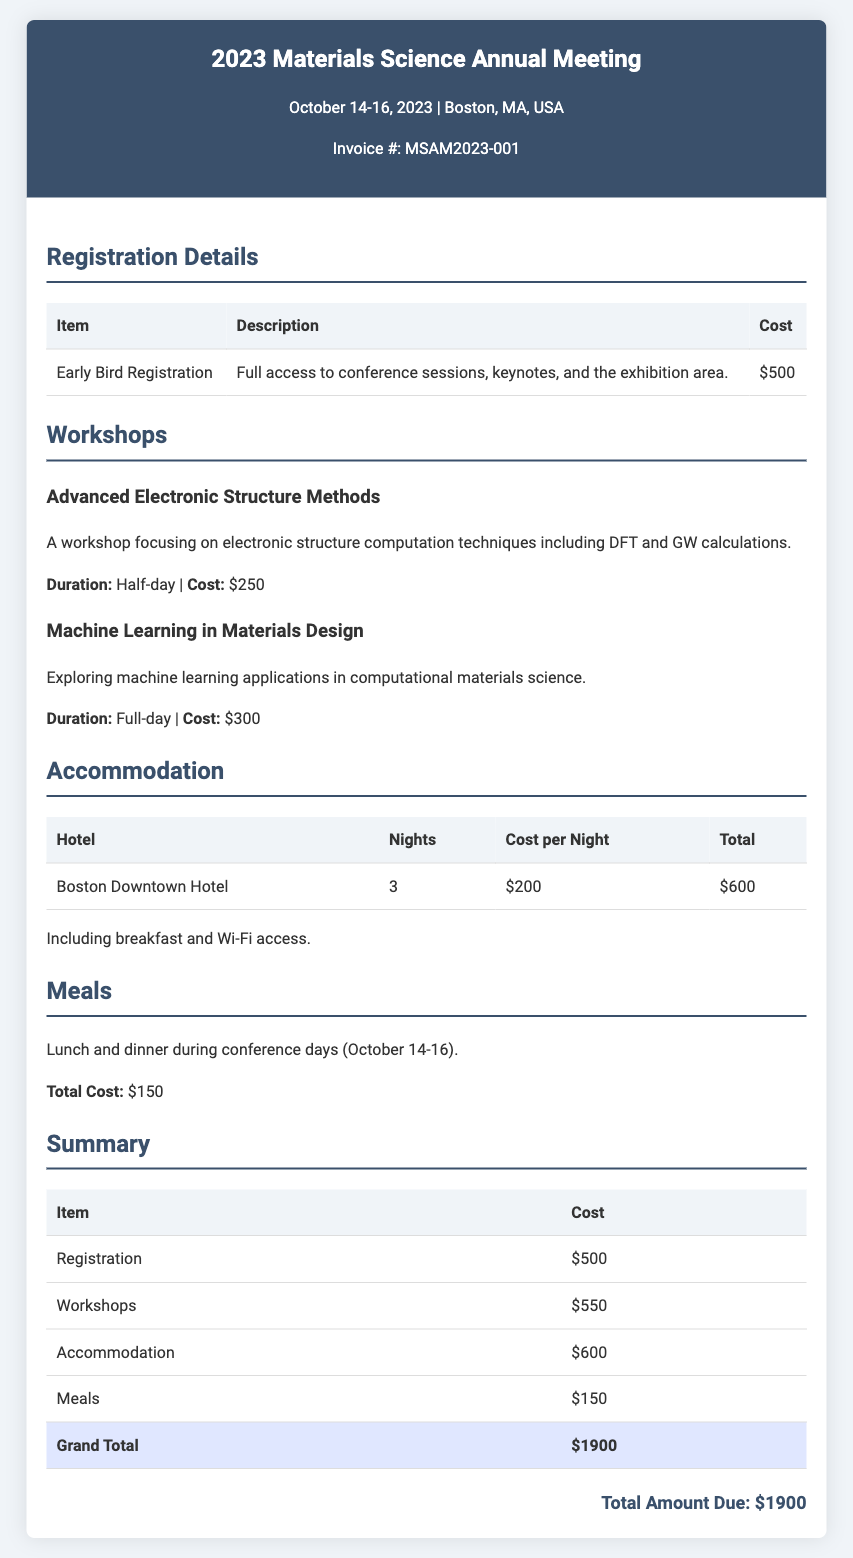What is the total amount due? The total amount due is emphasized at the bottom of the invoice, indicating the overall cost for attending the conference.
Answer: $1900 What is the cost of the Advanced Electronic Structure Methods workshop? The cost for this specific workshop is listed under the workshops section of the invoice.
Answer: $250 How many nights of accommodation are included? The invoice specifies the number of nights for the accommodation in the table for the hotel details.
Answer: 3 What is included with the hotel accommodation? The invoice mentions included amenities in a sentence following the accommodation table.
Answer: breakfast and Wi-Fi access What is the cost for meals during the conference? The details regarding meals are outlined in their own section, specifying the total cost for meals provided.
Answer: $150 What are the dates of the conference? The dates of the conference are stated prominently under the event name in the invoice header.
Answer: October 14-16, 2023 How much does the Early Bird Registration cost? The cost for the Early Bird Registration is listed in the registration details section of the invoice.
Answer: $500 What is the total cost for the workshops? The total cost for all workshops is summarized in the invoice under the summary section.
Answer: $550 Which hotel is mentioned for accommodation? The hotel name is specified in the accommodations table within the invoice details.
Answer: Boston Downtown Hotel 